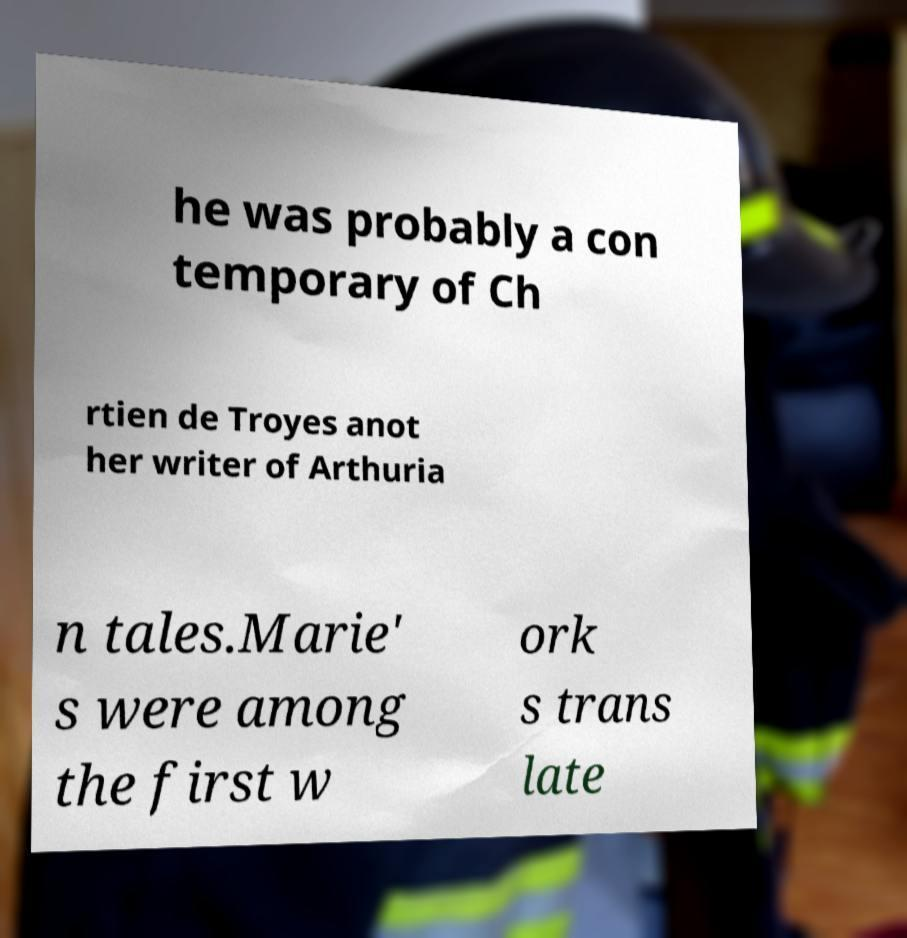There's text embedded in this image that I need extracted. Can you transcribe it verbatim? he was probably a con temporary of Ch rtien de Troyes anot her writer of Arthuria n tales.Marie' s were among the first w ork s trans late 